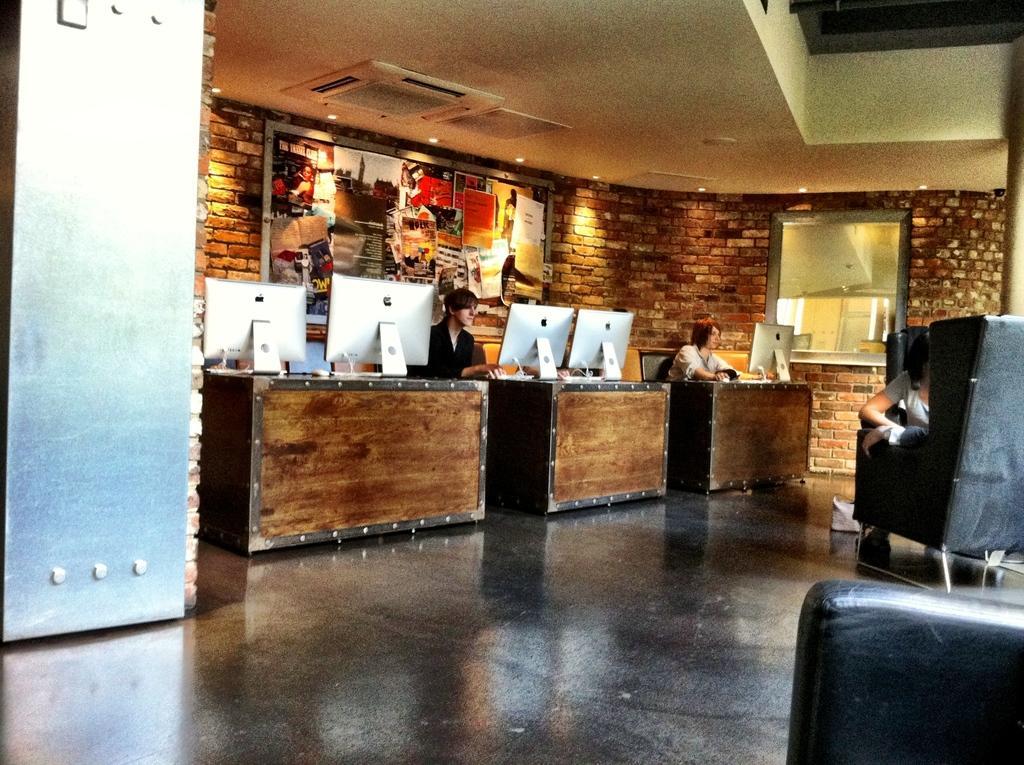How would you summarize this image in a sentence or two? In this image i can see two people are sitting on a chair in front of a table. 